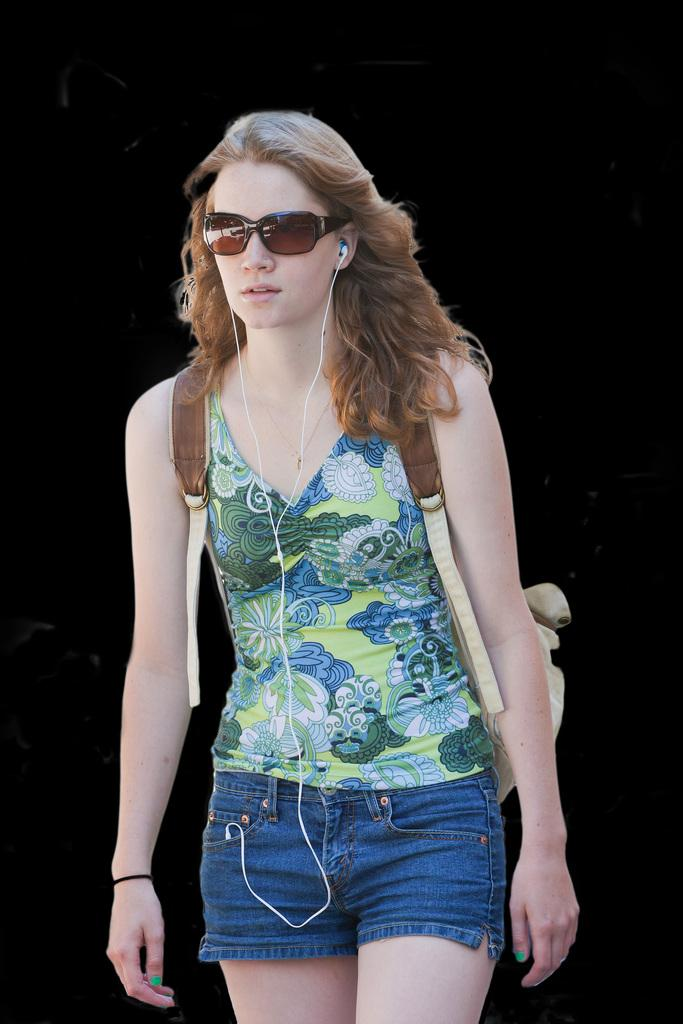Who is the main subject in the image? There is a lady in the image. Where is the lady positioned in the image? The lady is standing in the center of the image. What is the lady carrying on her back? The lady is wearing a backpack. What accessory is the lady wearing on her face? The lady is wearing glasses. What type of tin can be seen on the bed in the image? There is no tin or bed present in the image; it features a lady standing in the center. 